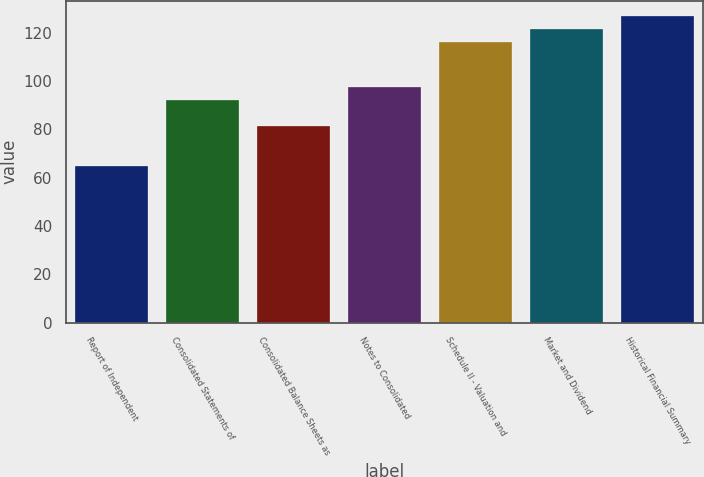Convert chart. <chart><loc_0><loc_0><loc_500><loc_500><bar_chart><fcel>Report of Independent<fcel>Consolidated Statements of<fcel>Consolidated Balance Sheets as<fcel>Notes to Consolidated<fcel>Schedule II - Valuation and<fcel>Market and Dividend<fcel>Historical Financial Summary<nl><fcel>65<fcel>92<fcel>81.2<fcel>97.4<fcel>116<fcel>121.4<fcel>126.8<nl></chart> 